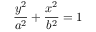<formula> <loc_0><loc_0><loc_500><loc_500>{ \frac { y ^ { 2 } } { a ^ { 2 } } } + { \frac { x ^ { 2 } } { b ^ { 2 } } } = 1</formula> 